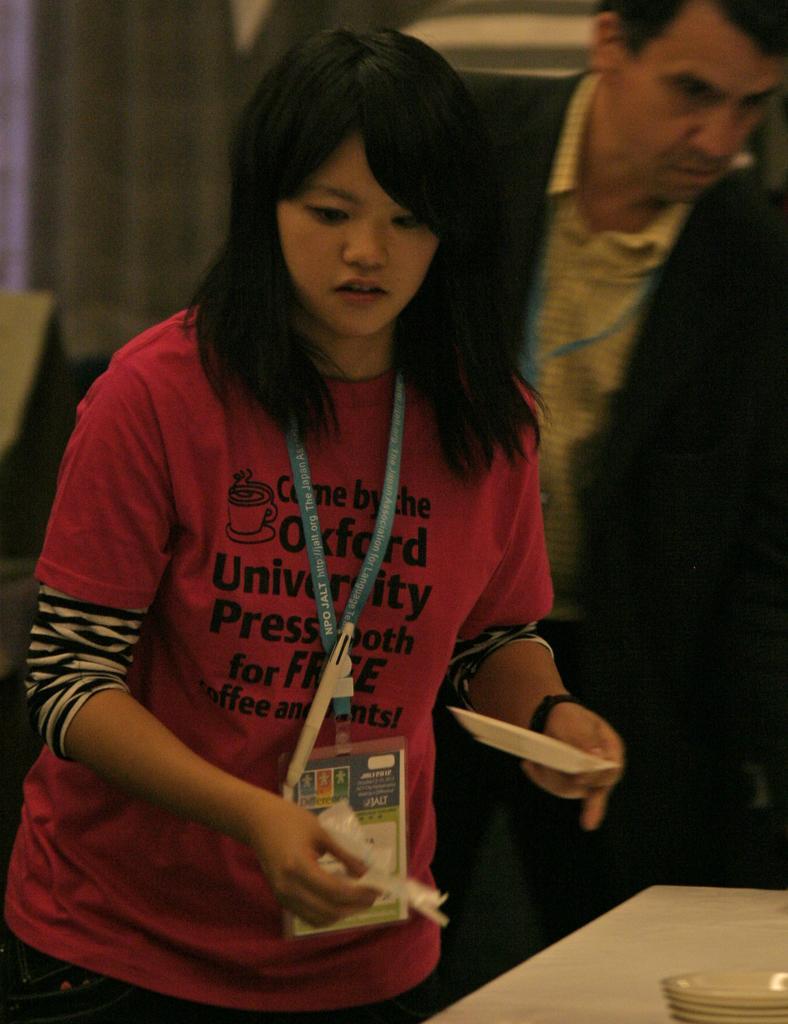In one or two sentences, can you explain what this image depicts? In this image I can see a women standing wearing a red T-Shirt and a blue colored badge she is holding a small plate on her hand. Behind the women,there is a man standing wearing a suit and white shirt. This is a table and some plates were placed on the table. At the background I can see a curtain cloth hanging to the hangers. 